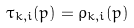Convert formula to latex. <formula><loc_0><loc_0><loc_500><loc_500>\tau _ { k , i } ( p ) = \rho _ { k , i } ( p )</formula> 